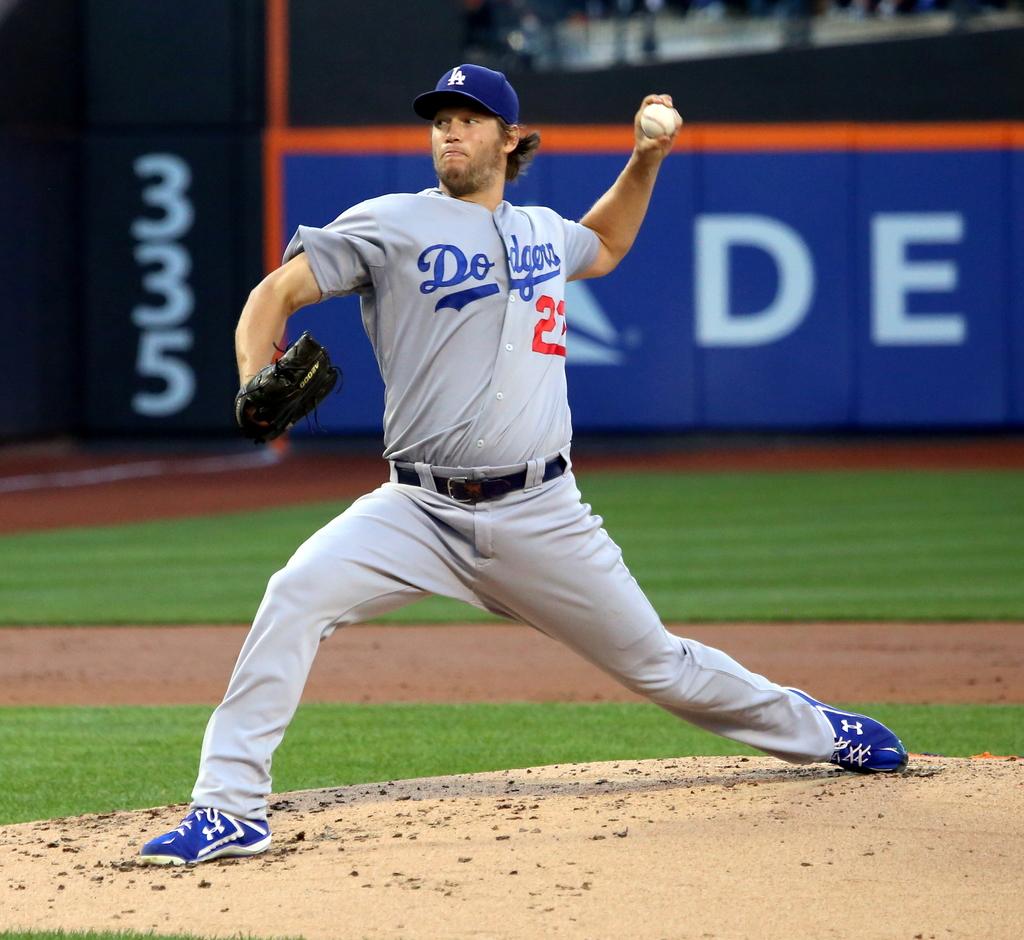What is his jersey number?
Provide a short and direct response. 23. 